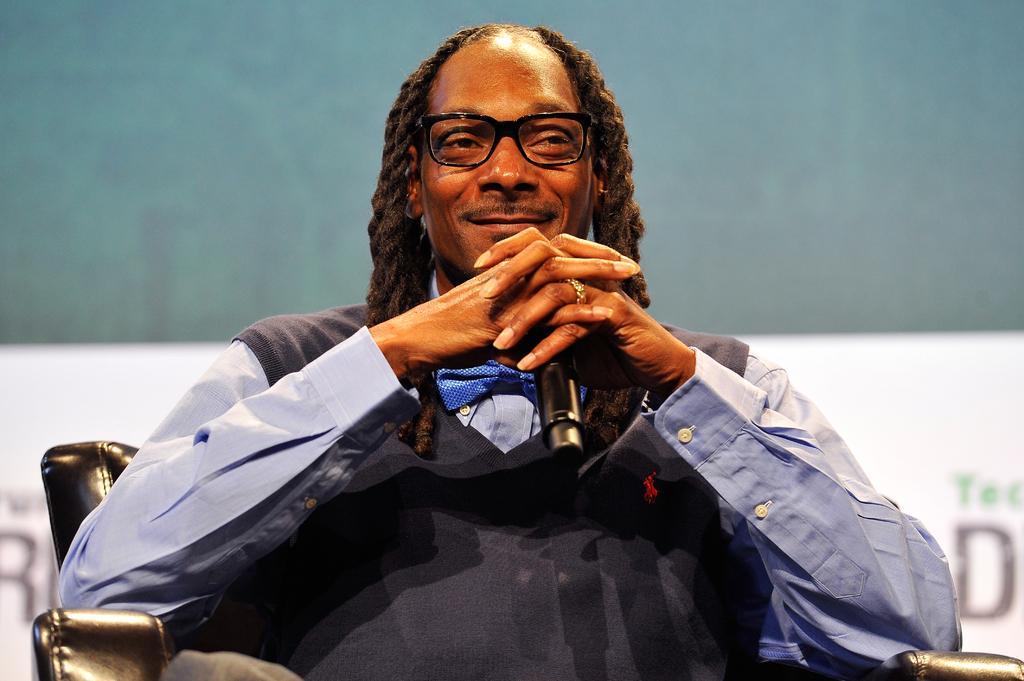How would you summarize this image in a sentence or two? In this image I can see a person wearing a blue color shirt ,wearing a spectacle and his smiling and sitting on sofa chair and background is in green color 